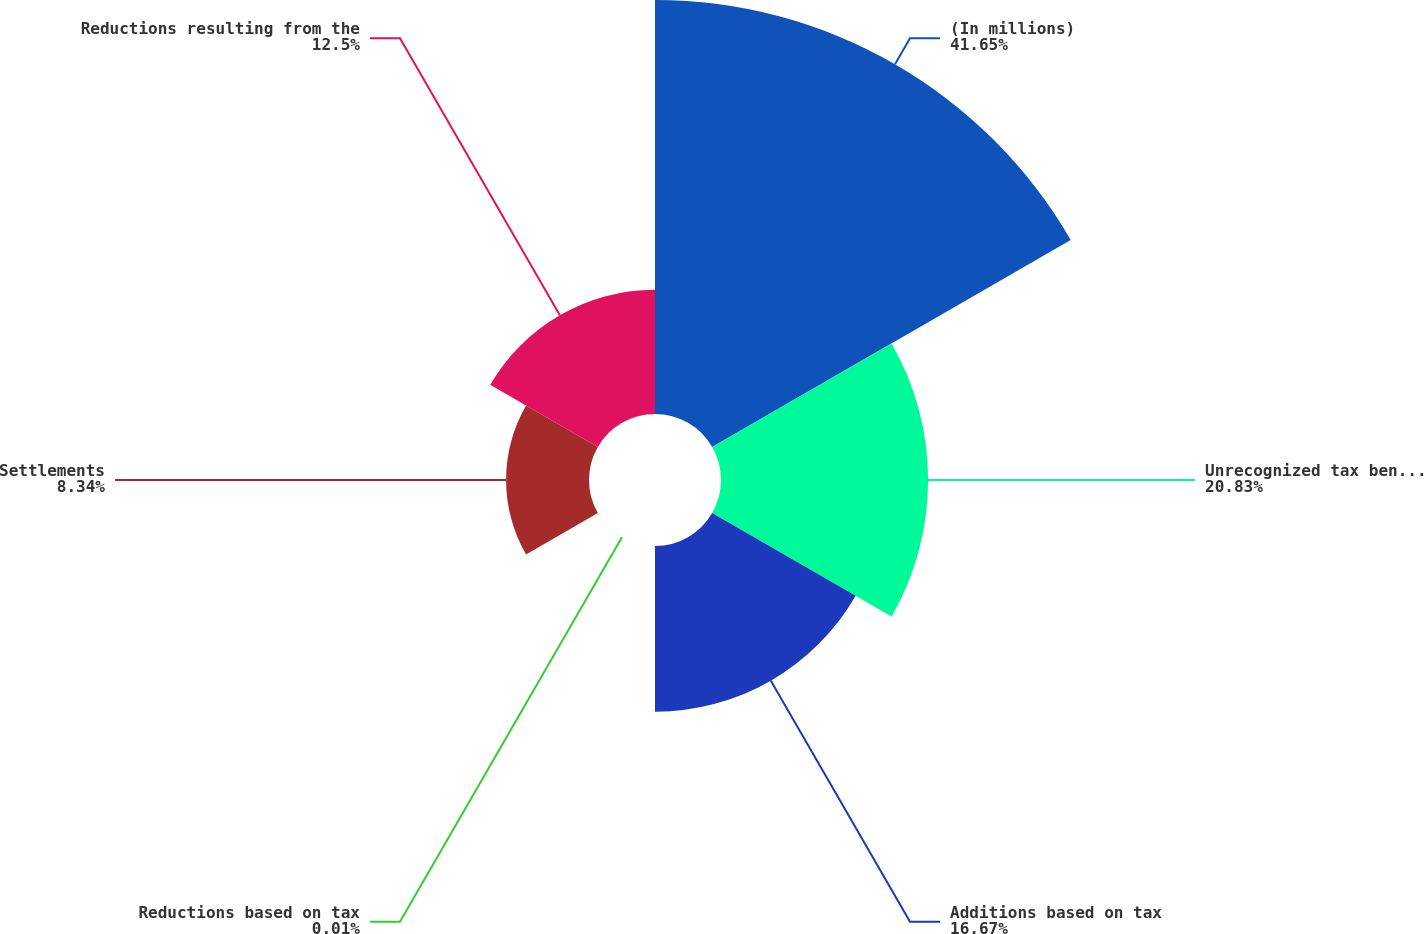<chart> <loc_0><loc_0><loc_500><loc_500><pie_chart><fcel>(In millions)<fcel>Unrecognized tax benefits<fcel>Additions based on tax<fcel>Reductions based on tax<fcel>Settlements<fcel>Reductions resulting from the<nl><fcel>41.64%<fcel>20.83%<fcel>16.67%<fcel>0.01%<fcel>8.34%<fcel>12.5%<nl></chart> 